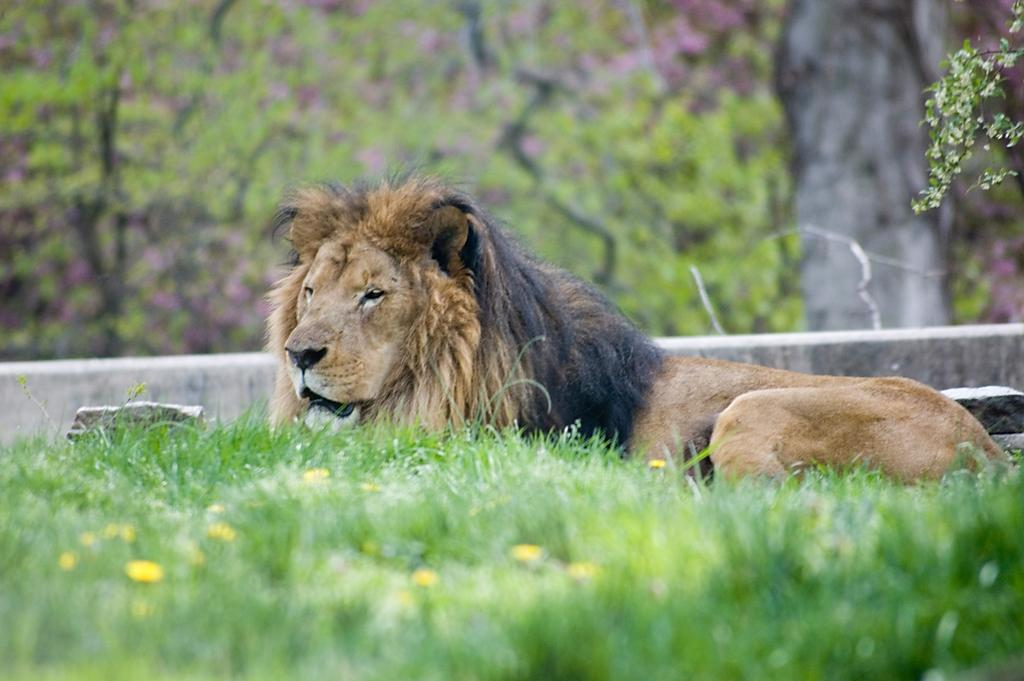What animal is in the center of the image? There is a lion in the center of the image. What type of vegetation is at the bottom of the image? There is grass at the bottom of the image. What can be seen in the background of the image? There are trees in the background of the image. What type of quince is being used to create a way for the lion to escape in the image? There is no quince or indication of an escape attempt in the image; it simply features a lion in the center. 